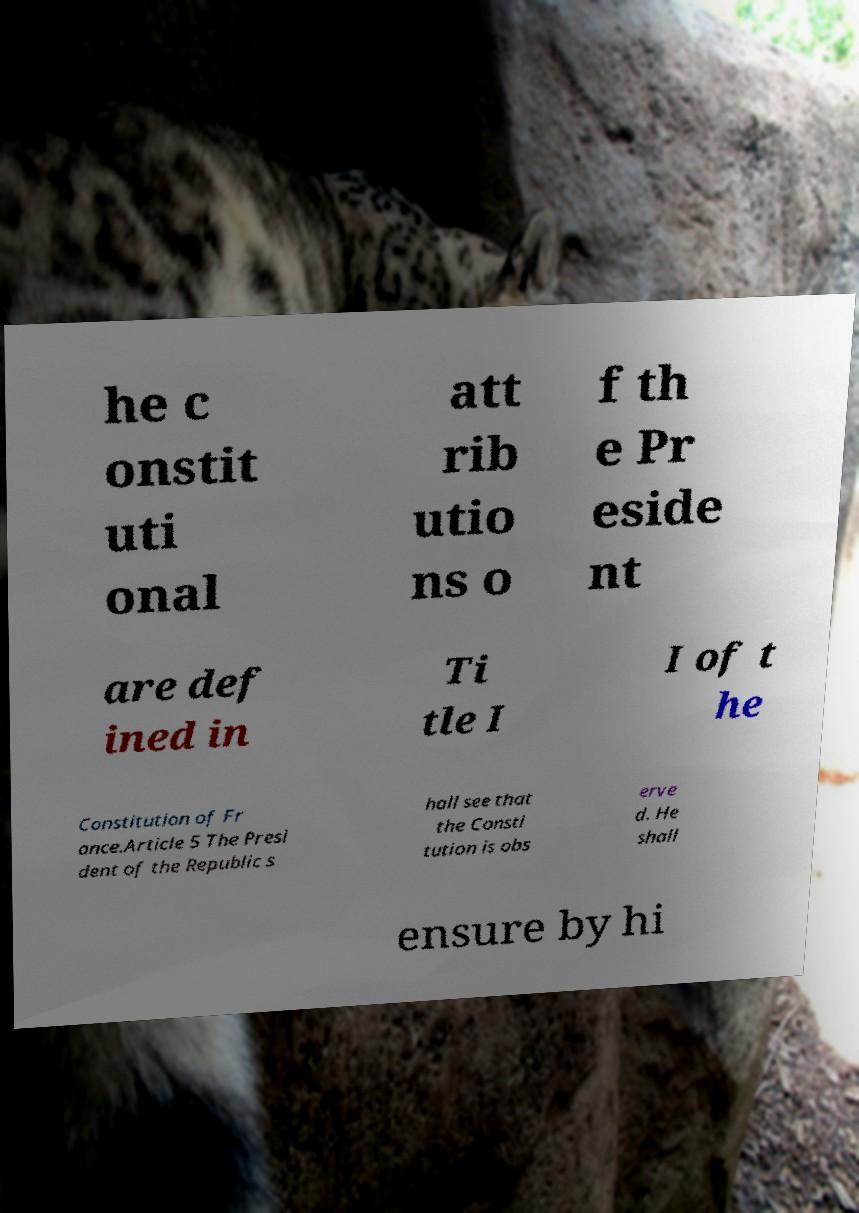For documentation purposes, I need the text within this image transcribed. Could you provide that? he c onstit uti onal att rib utio ns o f th e Pr eside nt are def ined in Ti tle I I of t he Constitution of Fr ance.Article 5 The Presi dent of the Republic s hall see that the Consti tution is obs erve d. He shall ensure by hi 